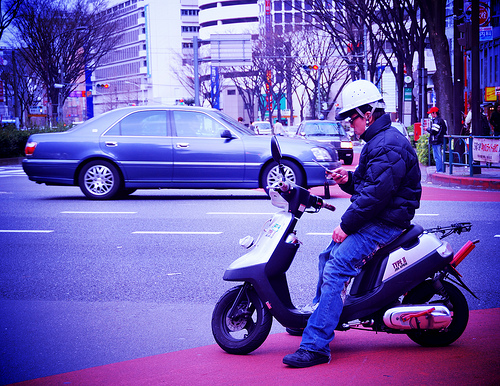What time of day does it look like in the image? Based on the lighting and the overall ambiance, it appears to be daytime with overcast skies, which suggests it might be either morning or afternoon. 